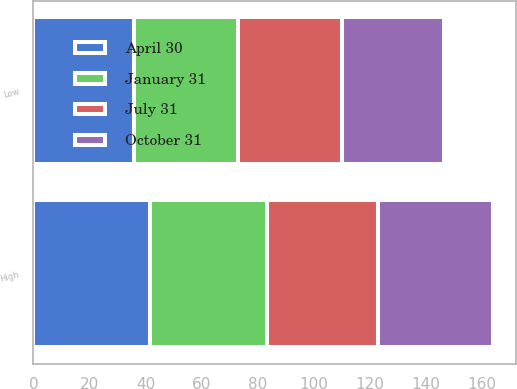<chart> <loc_0><loc_0><loc_500><loc_500><stacked_bar_chart><ecel><fcel>High<fcel>Low<nl><fcel>April 30<fcel>41.57<fcel>35.72<nl><fcel>October 31<fcel>41.1<fcel>36.38<nl><fcel>July 31<fcel>39.37<fcel>36.84<nl><fcel>January 31<fcel>41.75<fcel>37.28<nl></chart> 